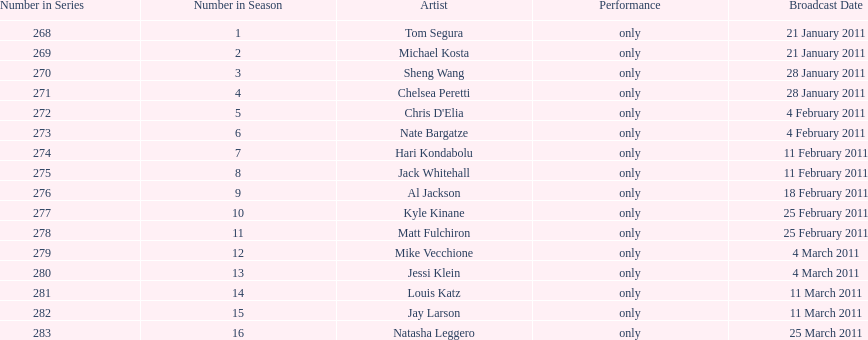Which month had the most performers? February. 